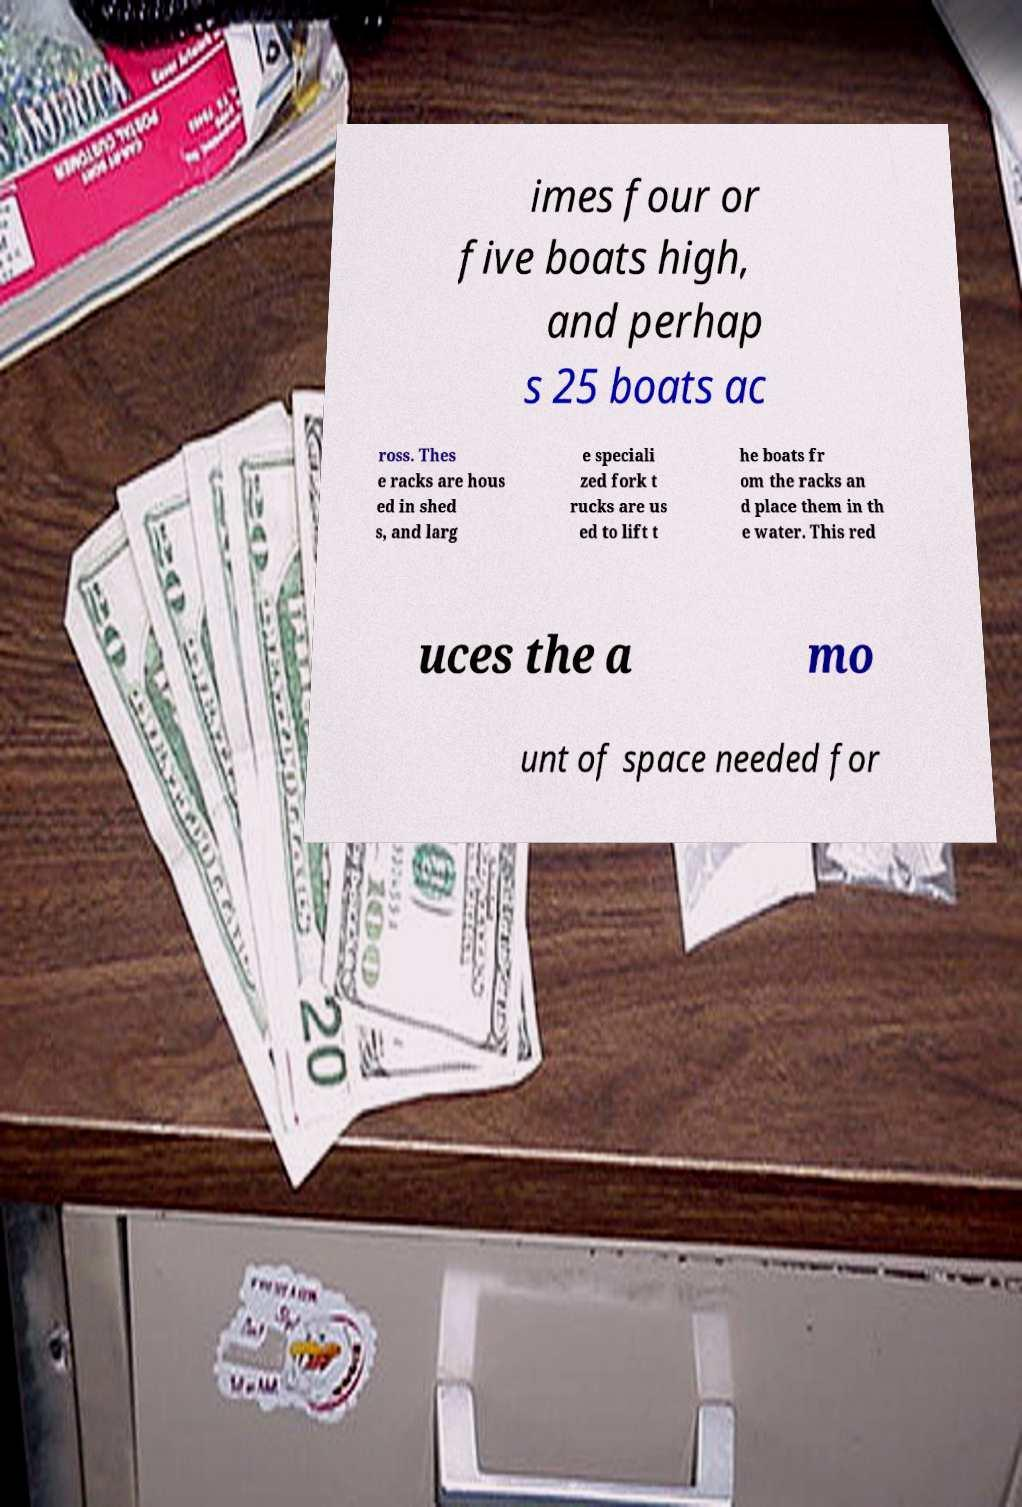Can you read and provide the text displayed in the image?This photo seems to have some interesting text. Can you extract and type it out for me? imes four or five boats high, and perhap s 25 boats ac ross. Thes e racks are hous ed in shed s, and larg e speciali zed fork t rucks are us ed to lift t he boats fr om the racks an d place them in th e water. This red uces the a mo unt of space needed for 